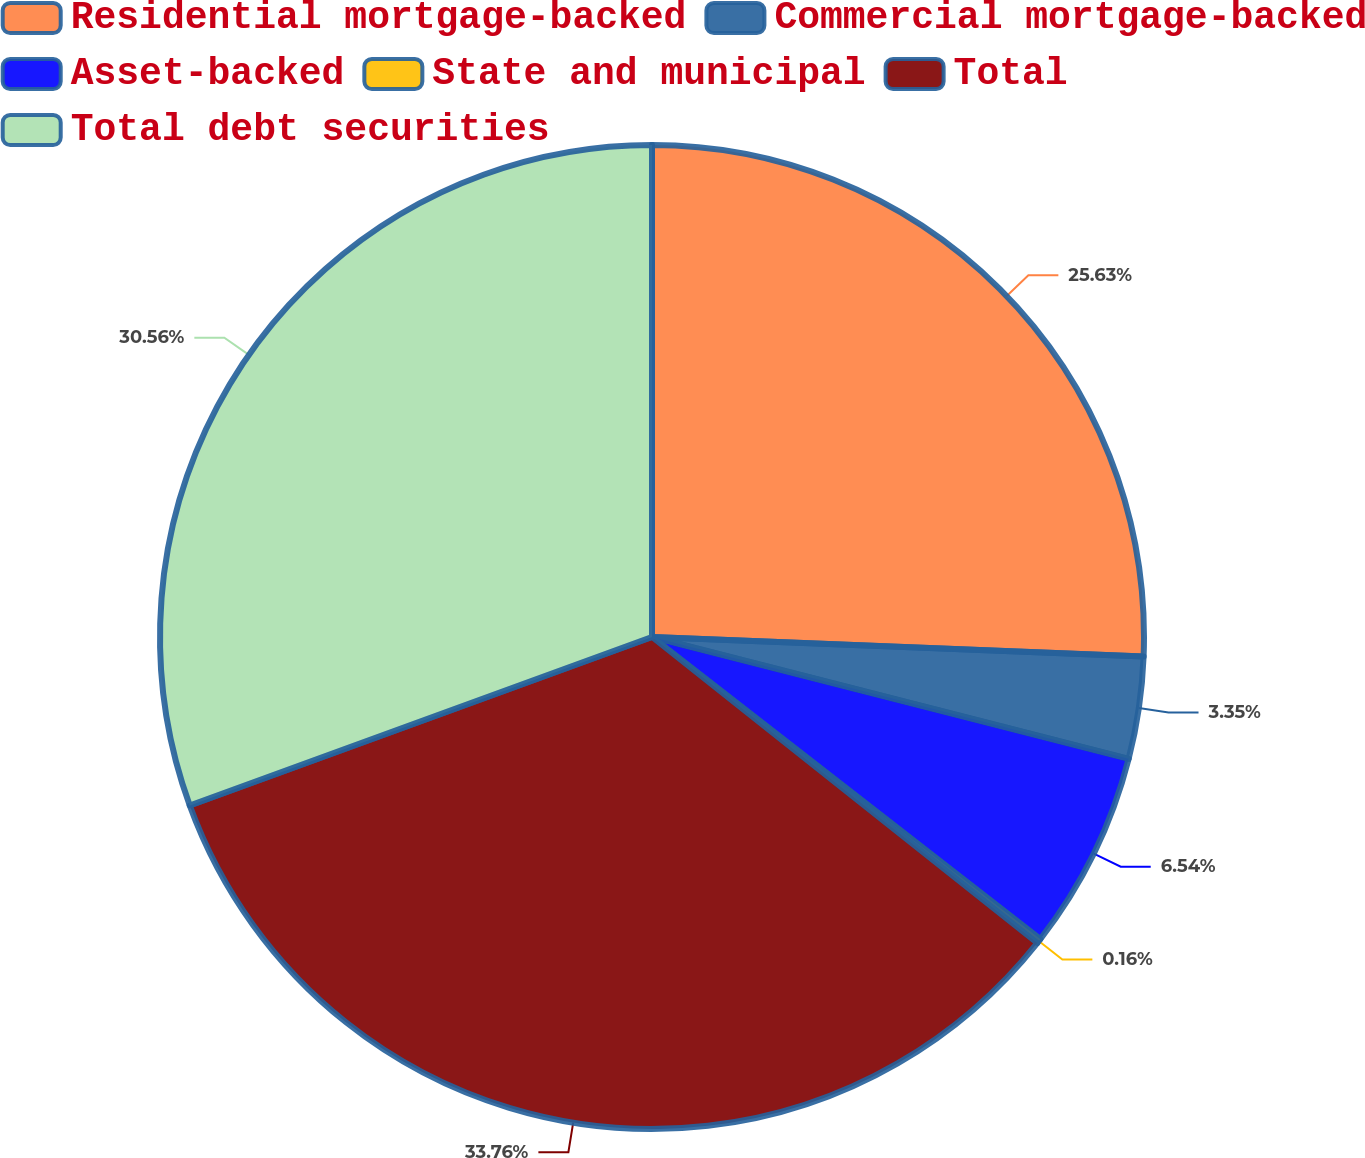Convert chart to OTSL. <chart><loc_0><loc_0><loc_500><loc_500><pie_chart><fcel>Residential mortgage-backed<fcel>Commercial mortgage-backed<fcel>Asset-backed<fcel>State and municipal<fcel>Total<fcel>Total debt securities<nl><fcel>25.63%<fcel>3.35%<fcel>6.54%<fcel>0.16%<fcel>33.75%<fcel>30.56%<nl></chart> 